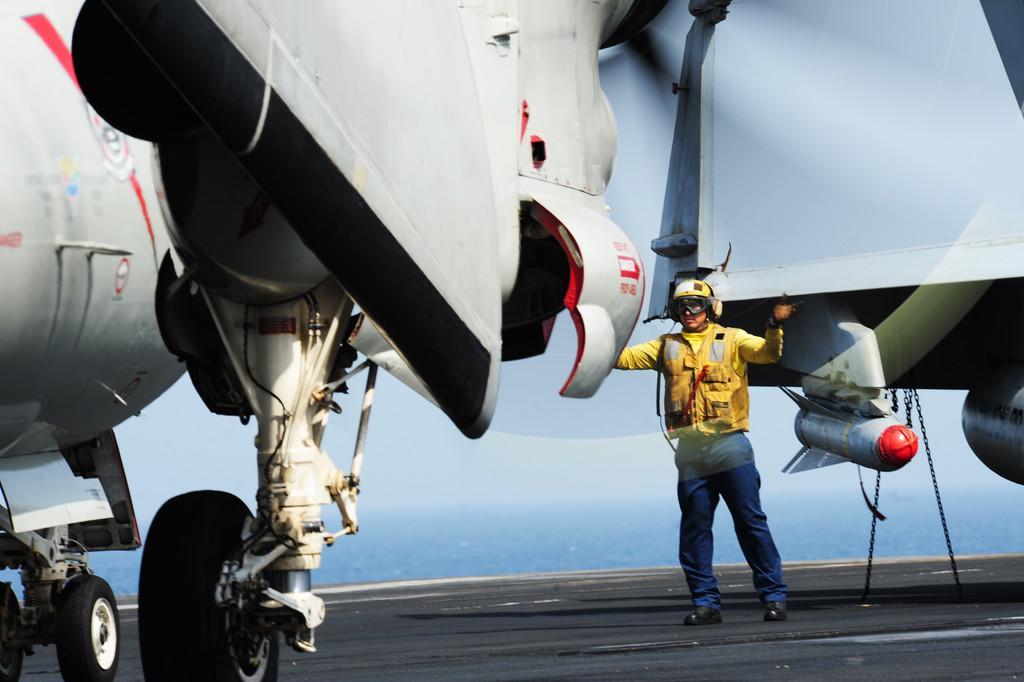Describe this image in one or two sentences. In the picture we can see under the plane with wheels which are fixed to it and a man standing with yellow dress and helmet and behind him we can see a sky. 